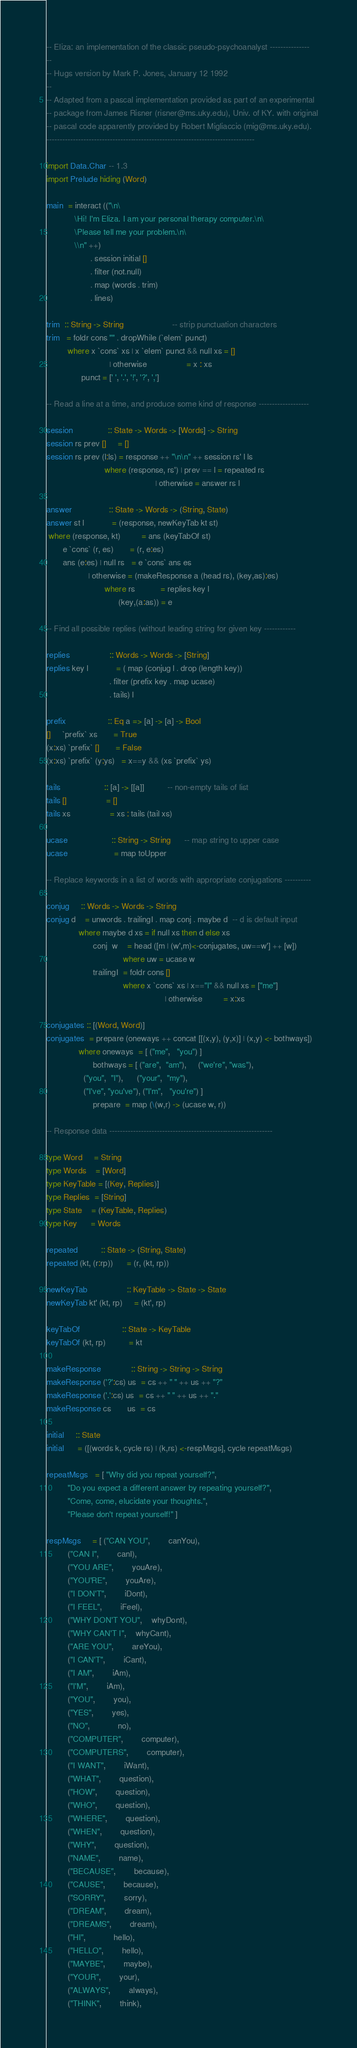<code> <loc_0><loc_0><loc_500><loc_500><_Haskell_>-- Eliza: an implementation of the classic pseudo-psychoanalyst ---------------
--
-- Hugs version by Mark P. Jones, January 12 1992
--
-- Adapted from a pascal implementation provided as part of an experimental
-- package from James Risner (risner@ms.uky.edu), Univ. of KY. with original
-- pascal code apparently provided by Robert Migliaccio (mig@ms.uky.edu).
-------------------------------------------------------------------------------

import Data.Char -- 1.3
import Prelude hiding (Word)

main  = interact (("\n\
		    \Hi! I'm Eliza. I am your personal therapy computer.\n\
		    \Please tell me your problem.\n\
		    \\n" ++)
                   . session initial []
                   . filter (not.null)
                   . map (words . trim)
                   . lines)

trim  :: String -> String                     -- strip punctuation characters
trim   = foldr cons "" . dropWhile (`elem` punct)
         where x `cons` xs | x `elem` punct && null xs = []
                           | otherwise                 = x : xs
               punct = [' ', '.', '!', '?', ',']

-- Read a line at a time, and produce some kind of response -------------------

session               :: State -> Words -> [Words] -> String
session rs prev []     = []
session rs prev (l:ls) = response ++ "\n\n" ++ session rs' l ls
                         where (response, rs') | prev == l = repeated rs
                                               | otherwise = answer rs l

answer                :: State -> Words -> (String, State)
answer st l            = (response, newKeyTab kt st)
 where (response, kt)         = ans (keyTabOf st)
       e `cons` (r, es)       = (r, e:es)
       ans (e:es) | null rs   = e `cons` ans es
                  | otherwise = (makeResponse a (head rs), (key,as):es)
                         where rs           = replies key l
                               (key,(a:as)) = e

-- Find all possible replies (without leading string for given key ------------

replies                 :: Words -> Words -> [String]
replies key l            = ( map (conjug l . drop (length key))
                           . filter (prefix key . map ucase)
                           . tails) l

prefix                  :: Eq a => [a] -> [a] -> Bool
[]     `prefix` xs       = True
(x:xs) `prefix` []       = False
(x:xs) `prefix` (y:ys)   = x==y && (xs `prefix` ys)

tails                   :: [a] -> [[a]]          -- non-empty tails of list
tails []                 = []
tails xs                 = xs : tails (tail xs)

ucase                   :: String -> String      -- map string to upper case
ucase                    = map toUpper

-- Replace keywords in a list of words with appropriate conjugations ----------

conjug     :: Words -> Words -> String
conjug d    = unwords . trailingI . map conj . maybe d  -- d is default input
              where maybe d xs = if null xs then d else xs
                    conj  w    = head ([m | (w',m)<-conjugates, uw==w'] ++ [w])
                                 where uw = ucase w
                    trailingI  = foldr cons []
                                 where x `cons` xs | x=="I" && null xs = ["me"]
                                                   | otherwise         = x:xs

conjugates :: [(Word, Word)]
conjugates  = prepare (oneways ++ concat [[(x,y), (y,x)] | (x,y) <- bothways])
              where oneways  = [ ("me",   "you") ]
                    bothways = [ ("are",  "am"),     ("we're", "was"),
				("you",  "I"),      ("your",  "my"),
				("I've", "you've"), ("I'm",   "you're") ]
                    prepare  = map (\(w,r) -> (ucase w, r))

-- Response data --------------------------------------------------------------

type Word     = String
type Words    = [Word]
type KeyTable = [(Key, Replies)]
type Replies  = [String]
type State    = (KeyTable, Replies)
type Key      = Words

repeated		  :: State -> (String, State)
repeated (kt, (r:rp))      = (r, (kt, rp))

newKeyTab                 :: KeyTable -> State -> State
newKeyTab kt' (kt, rp)     = (kt', rp)

keyTabOf                  :: State -> KeyTable
keyTabOf (kt, rp)          = kt

makeResponse             :: String -> String -> String
makeResponse ('?':cs) us  = cs ++ " " ++ us ++ "?"
makeResponse ('.':cs) us  = cs ++ " " ++ us ++ "."
makeResponse cs       us  = cs

initial     :: State
initial      = ([(words k, cycle rs) | (k,rs) <-respMsgs], cycle repeatMsgs)

repeatMsgs   = [ "Why did you repeat yourself?",
		 "Do you expect a different answer by repeating yourself?",
		 "Come, come, elucidate your thoughts.",
		 "Please don't repeat yourself!" ]

respMsgs     = [ ("CAN YOU",		canYou),
		 ("CAN I",		canI),
		 ("YOU ARE",		youAre),
		 ("YOU'RE",		youAre),
		 ("I DON'T",		iDont),
		 ("I FEEL",		iFeel),
		 ("WHY DON'T YOU",	whyDont),
		 ("WHY CAN'T I",	whyCant),
		 ("ARE YOU",		areYou), 
		 ("I CAN'T",		iCant),
		 ("I AM",		iAm),
		 ("I'M",		iAm),
		 ("YOU", 		you),
		 ("YES",		yes),
		 ("NO",			no),
		 ("COMPUTER",		computer),
		 ("COMPUTERS",		computer),
		 ("I WANT",		iWant),
		 ("WHAT",		question),
		 ("HOW",		question),
		 ("WHO",		question),
		 ("WHERE",		question),
		 ("WHEN",		question),
		 ("WHY",		question),
		 ("NAME",		name),
		 ("BECAUSE",		because),
		 ("CAUSE",		because),
		 ("SORRY",		sorry),
		 ("DREAM",		dream),
		 ("DREAMS",		dream),
		 ("HI",			hello),
		 ("HELLO",		hello),
		 ("MAYBE",		maybe),
		 ("YOUR",		your),
		 ("ALWAYS",		always),
		 ("THINK",		think),</code> 